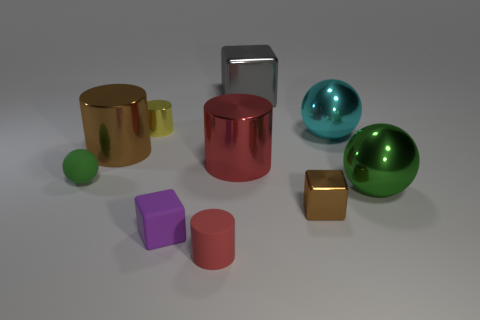How many objects are either cylinders that are in front of the large brown shiny cylinder or yellow cylinders? In the image, there are two yellow cylinders, and one small red cylinder is positioned in front of the large brown shiny cylinder. Therefore, the total count of objects meeting the criteria is three. 